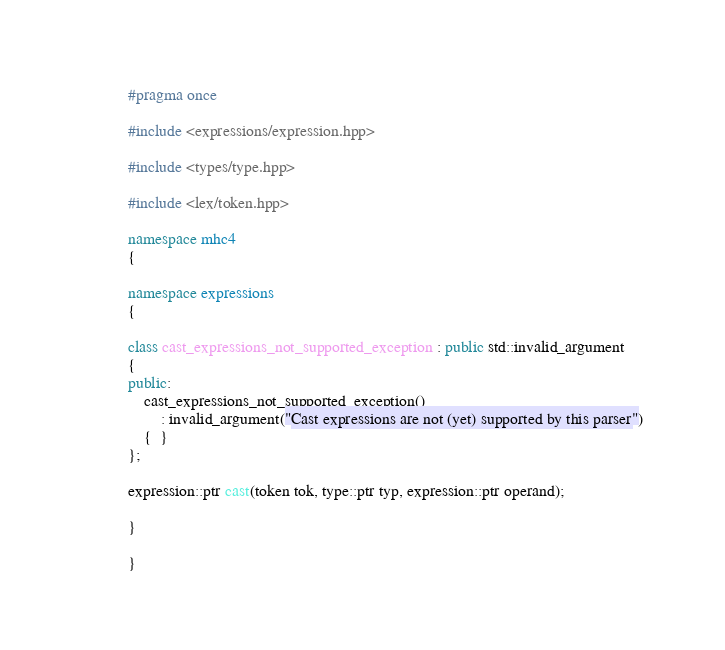<code> <loc_0><loc_0><loc_500><loc_500><_C++_>#pragma once

#include <expressions/expression.hpp>

#include <types/type.hpp>

#include <lex/token.hpp>

namespace mhc4
{

namespace expressions
{

class cast_expressions_not_supported_exception : public std::invalid_argument
{
public:
    cast_expressions_not_supported_exception()
        : invalid_argument("Cast expressions are not (yet) supported by this parser")
    {  }
};

expression::ptr cast(token tok, type::ptr typ, expression::ptr operand);

}

}
</code> 